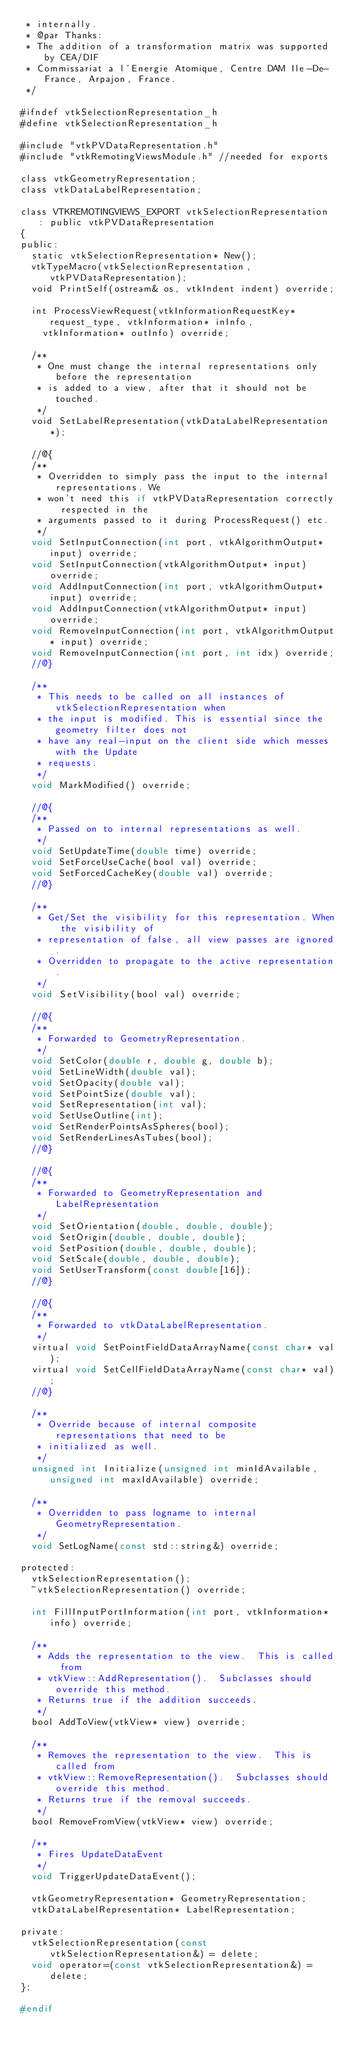Convert code to text. <code><loc_0><loc_0><loc_500><loc_500><_C_> * internally.
 * @par Thanks:
 * The addition of a transformation matrix was supported by CEA/DIF
 * Commissariat a l'Energie Atomique, Centre DAM Ile-De-France, Arpajon, France.
 */

#ifndef vtkSelectionRepresentation_h
#define vtkSelectionRepresentation_h

#include "vtkPVDataRepresentation.h"
#include "vtkRemotingViewsModule.h" //needed for exports

class vtkGeometryRepresentation;
class vtkDataLabelRepresentation;

class VTKREMOTINGVIEWS_EXPORT vtkSelectionRepresentation : public vtkPVDataRepresentation
{
public:
  static vtkSelectionRepresentation* New();
  vtkTypeMacro(vtkSelectionRepresentation, vtkPVDataRepresentation);
  void PrintSelf(ostream& os, vtkIndent indent) override;

  int ProcessViewRequest(vtkInformationRequestKey* request_type, vtkInformation* inInfo,
    vtkInformation* outInfo) override;

  /**
   * One must change the internal representations only before the representation
   * is added to a view, after that it should not be touched.
   */
  void SetLabelRepresentation(vtkDataLabelRepresentation*);

  //@{
  /**
   * Overridden to simply pass the input to the internal representations. We
   * won't need this if vtkPVDataRepresentation correctly respected in the
   * arguments passed to it during ProcessRequest() etc.
   */
  void SetInputConnection(int port, vtkAlgorithmOutput* input) override;
  void SetInputConnection(vtkAlgorithmOutput* input) override;
  void AddInputConnection(int port, vtkAlgorithmOutput* input) override;
  void AddInputConnection(vtkAlgorithmOutput* input) override;
  void RemoveInputConnection(int port, vtkAlgorithmOutput* input) override;
  void RemoveInputConnection(int port, int idx) override;
  //@}

  /**
   * This needs to be called on all instances of vtkSelectionRepresentation when
   * the input is modified. This is essential since the geometry filter does not
   * have any real-input on the client side which messes with the Update
   * requests.
   */
  void MarkModified() override;

  //@{
  /**
   * Passed on to internal representations as well.
   */
  void SetUpdateTime(double time) override;
  void SetForceUseCache(bool val) override;
  void SetForcedCacheKey(double val) override;
  //@}

  /**
   * Get/Set the visibility for this representation. When the visibility of
   * representation of false, all view passes are ignored.
   * Overridden to propagate to the active representation.
   */
  void SetVisibility(bool val) override;

  //@{
  /**
   * Forwarded to GeometryRepresentation.
   */
  void SetColor(double r, double g, double b);
  void SetLineWidth(double val);
  void SetOpacity(double val);
  void SetPointSize(double val);
  void SetRepresentation(int val);
  void SetUseOutline(int);
  void SetRenderPointsAsSpheres(bool);
  void SetRenderLinesAsTubes(bool);
  //@}

  //@{
  /**
   * Forwarded to GeometryRepresentation and LabelRepresentation
   */
  void SetOrientation(double, double, double);
  void SetOrigin(double, double, double);
  void SetPosition(double, double, double);
  void SetScale(double, double, double);
  void SetUserTransform(const double[16]);
  //@}

  //@{
  /**
   * Forwarded to vtkDataLabelRepresentation.
   */
  virtual void SetPointFieldDataArrayName(const char* val);
  virtual void SetCellFieldDataArrayName(const char* val);
  //@}

  /**
   * Override because of internal composite representations that need to be
   * initialized as well.
   */
  unsigned int Initialize(unsigned int minIdAvailable, unsigned int maxIdAvailable) override;

  /**
   * Overridden to pass logname to internal GeometryRepresentation.
   */
  void SetLogName(const std::string&) override;

protected:
  vtkSelectionRepresentation();
  ~vtkSelectionRepresentation() override;

  int FillInputPortInformation(int port, vtkInformation* info) override;

  /**
   * Adds the representation to the view.  This is called from
   * vtkView::AddRepresentation().  Subclasses should override this method.
   * Returns true if the addition succeeds.
   */
  bool AddToView(vtkView* view) override;

  /**
   * Removes the representation to the view.  This is called from
   * vtkView::RemoveRepresentation().  Subclasses should override this method.
   * Returns true if the removal succeeds.
   */
  bool RemoveFromView(vtkView* view) override;

  /**
   * Fires UpdateDataEvent
   */
  void TriggerUpdateDataEvent();

  vtkGeometryRepresentation* GeometryRepresentation;
  vtkDataLabelRepresentation* LabelRepresentation;

private:
  vtkSelectionRepresentation(const vtkSelectionRepresentation&) = delete;
  void operator=(const vtkSelectionRepresentation&) = delete;
};

#endif
</code> 